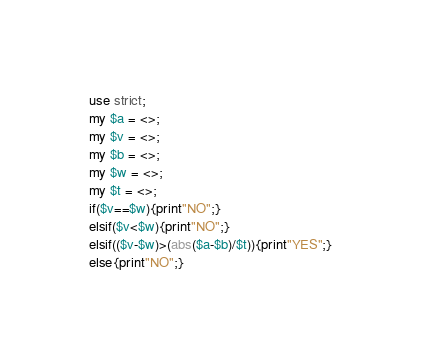<code> <loc_0><loc_0><loc_500><loc_500><_Perl_>use strict;
my $a = <>;
my $v = <>;
my $b = <>;
my $w = <>;
my $t = <>;
if($v==$w){print"NO";}
elsif($v<$w){print"NO";}
elsif(($v-$w)>(abs($a-$b)/$t)){print"YES";}
else{print"NO";}</code> 